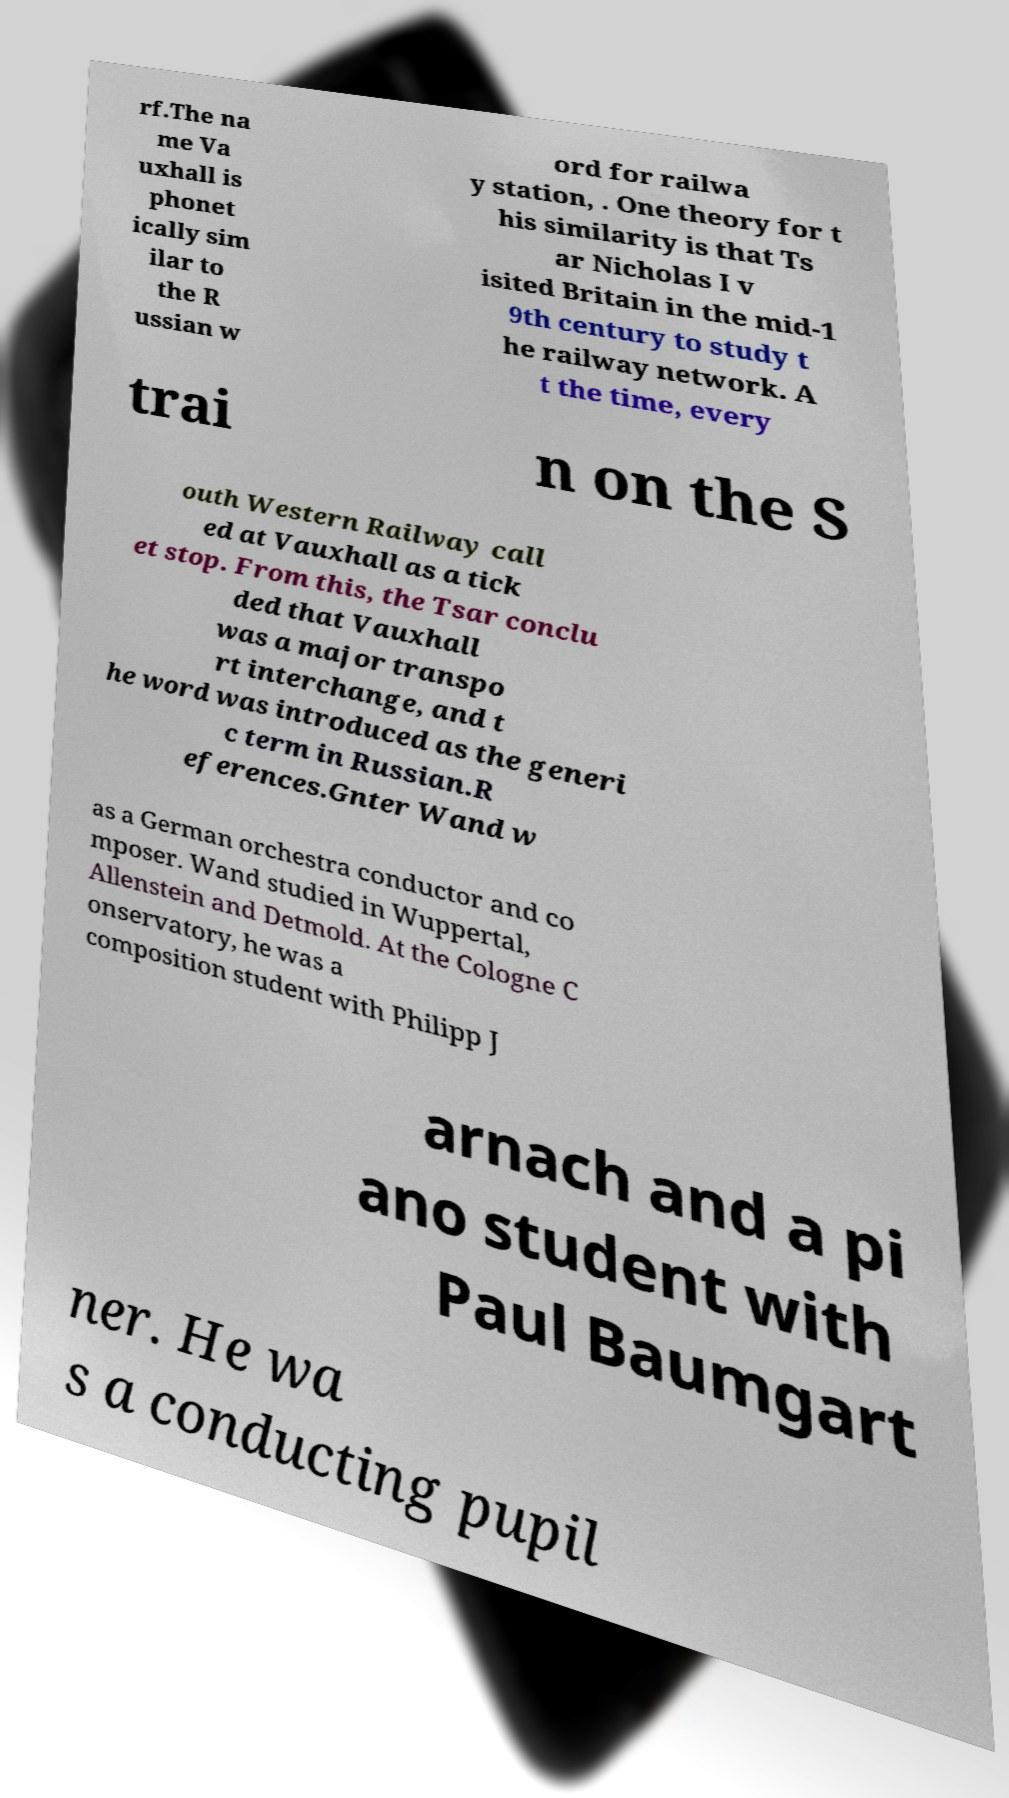What messages or text are displayed in this image? I need them in a readable, typed format. rf.The na me Va uxhall is phonet ically sim ilar to the R ussian w ord for railwa y station, . One theory for t his similarity is that Ts ar Nicholas I v isited Britain in the mid-1 9th century to study t he railway network. A t the time, every trai n on the S outh Western Railway call ed at Vauxhall as a tick et stop. From this, the Tsar conclu ded that Vauxhall was a major transpo rt interchange, and t he word was introduced as the generi c term in Russian.R eferences.Gnter Wand w as a German orchestra conductor and co mposer. Wand studied in Wuppertal, Allenstein and Detmold. At the Cologne C onservatory, he was a composition student with Philipp J arnach and a pi ano student with Paul Baumgart ner. He wa s a conducting pupil 